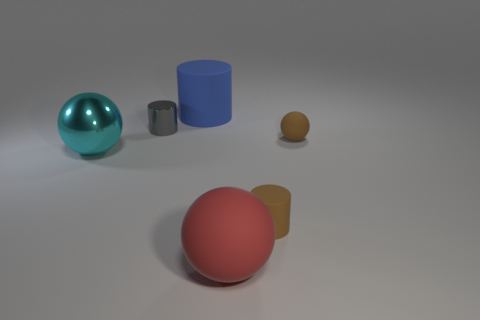Is the tiny brown sphere made of the same material as the large sphere that is behind the big red object?
Keep it short and to the point. No. Are there an equal number of rubber cylinders to the left of the large cyan metal sphere and small brown balls on the left side of the gray metallic thing?
Your answer should be very brief. Yes. What material is the gray cylinder?
Your response must be concise. Metal. The metal object that is the same size as the blue cylinder is what color?
Give a very brief answer. Cyan. There is a large ball that is behind the big red ball; are there any tiny matte cylinders to the left of it?
Give a very brief answer. No. How many cylinders are brown rubber things or large objects?
Ensure brevity in your answer.  2. What is the size of the object that is in front of the tiny cylinder on the right side of the rubber cylinder that is to the left of the brown rubber cylinder?
Offer a terse response. Large. There is a metal cylinder; are there any tiny gray cylinders behind it?
Your answer should be compact. No. What is the shape of the object that is the same color as the small sphere?
Offer a very short reply. Cylinder. What number of objects are matte spheres behind the large cyan object or blue things?
Ensure brevity in your answer.  2. 